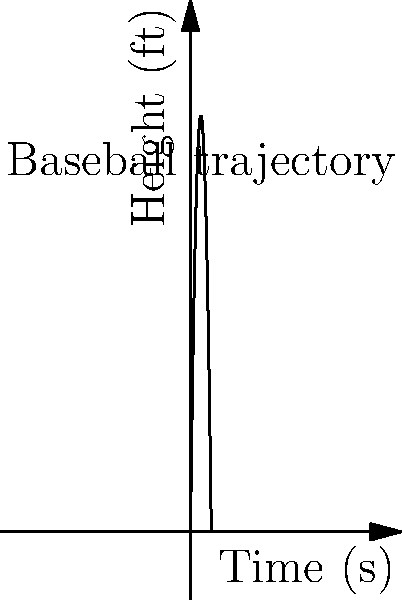As a sports reporter covering a baseball game at Nassau Coliseum, you observe a batter hit a home run. The ball's trajectory can be modeled by the function $h(t) = -16t^2 + 80t$, where $h$ is the height in feet and $t$ is the time in seconds. Use calculus to determine the maximum height reached by the baseball. To find the maximum height of the baseball's trajectory, we need to follow these steps:

1) The maximum height occurs at the vertex of the parabola, which is where the derivative of the function equals zero.

2) First, let's find the derivative of $h(t)$:
   $h'(t) = \frac{d}{dt}(-16t^2 + 80t) = -32t + 80$

3) Now, set the derivative equal to zero and solve for $t$:
   $-32t + 80 = 0$
   $-32t = -80$
   $t = \frac{80}{32} = 2.5$ seconds

4) This critical point ($t = 2.5$) gives us the time when the ball reaches its maximum height.

5) To find the maximum height, we substitute this $t$ value back into our original function:
   $h(2.5) = -16(2.5)^2 + 80(2.5)$
   $= -16(6.25) + 200$
   $= -100 + 200$
   $= 100$ feet

Therefore, the baseball reaches a maximum height of 100 feet after 2.5 seconds.
Answer: 100 feet 